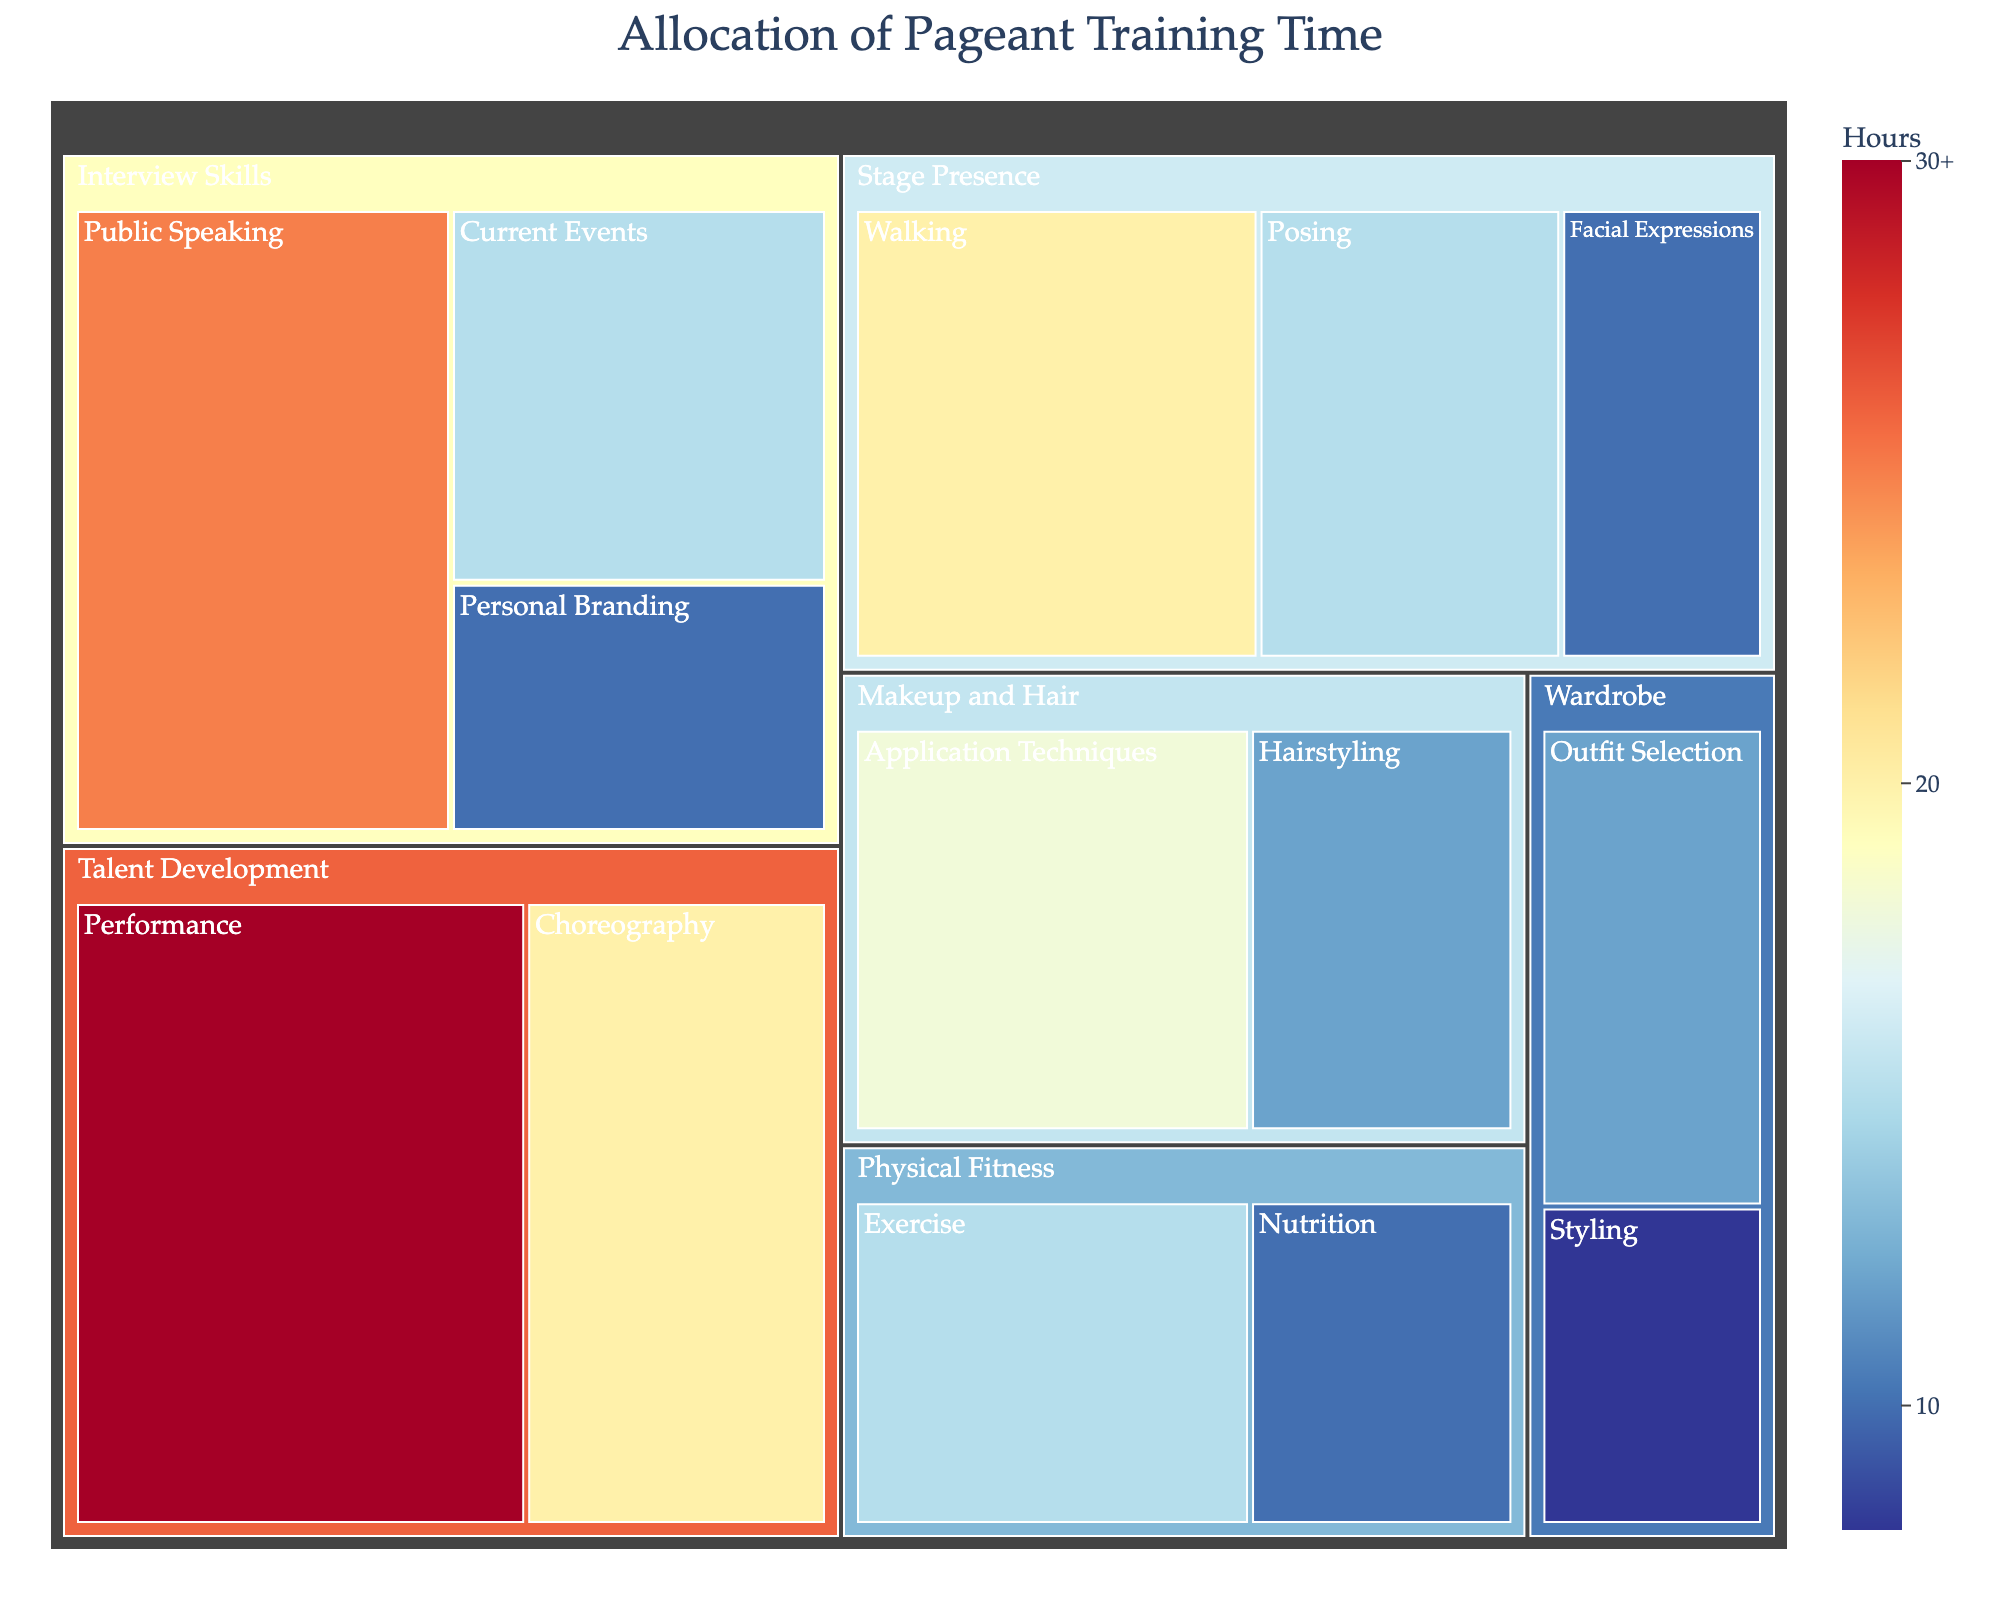What is the title of the treemap? The title is located at the top of the treemap and it summarizes the main topic of the visualized data.
Answer: Allocation of Pageant Training Time Which category has the highest allocation of hours? Examine the main blocks within the treemap and identify the one with the largest area (usually indicated by the depth of the color as well).
Answer: Talent Development How many hours are allocated to Walking under Stage Presence? Locate the "Stage Presence" block and find the "Walking" subcategory inside it. The hours are typically displayed inside the subcategory block.
Answer: 20 What are the total hours allocated to Interview Skills? Sum up the hours for all subcategories under the "Interview Skills" main block. These subcategories are Public Speaking, Current Events, and Personal Branding. Total hours = 25 + 15 + 10.
Answer: 50 Which has more hours allocated: Hairstyling or Styling? Compare the hours indicated within the "Hairstyling" subcategory under "Makeup and Hair" and the "Styling" subcategory under "Wardrobe".
Answer: Hairstyling What is the combined total of hours dedicated to Physical Fitness and Wardrobe? Sum the hours of all subcategories under both "Physical Fitness" (Exercise and Nutrition) and "Wardrobe" (Outfit Selection and Styling). Total hours = (15 + 10) + (12 + 8).
Answer: 45 Which subcategory under Talent Development has the highest hours, and how many hours are they? Check the subcategories within "Talent Development" and compare their hours to find the highest one.
Answer: Performance, 30 How do the hours dedicated to Application Techniques in Makeup and Hair compare with those dedicated to Walking in Stage Presence? Identify the hours for both "Application Techniques" under "Makeup and Hair" and "Walking" under "Stage Presence" and compare them directly.
Answer: Application Techniques has fewer hours than Walking How many categories have a total allocated time of less than 30 hours? Sum the hours of subcategories within each main category and count how many of these totals are less than 30 hours.
Answer: Four categories (Stage Presence, Wardrobe, Physical Fitness, and Makeup and Hair) What is the average amount of time spent on the three subcategories of Stage Presence? Add the hours of Walking, Posing, and Facial Expressions and divide by 3. Calculation: (20 + 15 + 10) / 3.
Answer: 15 